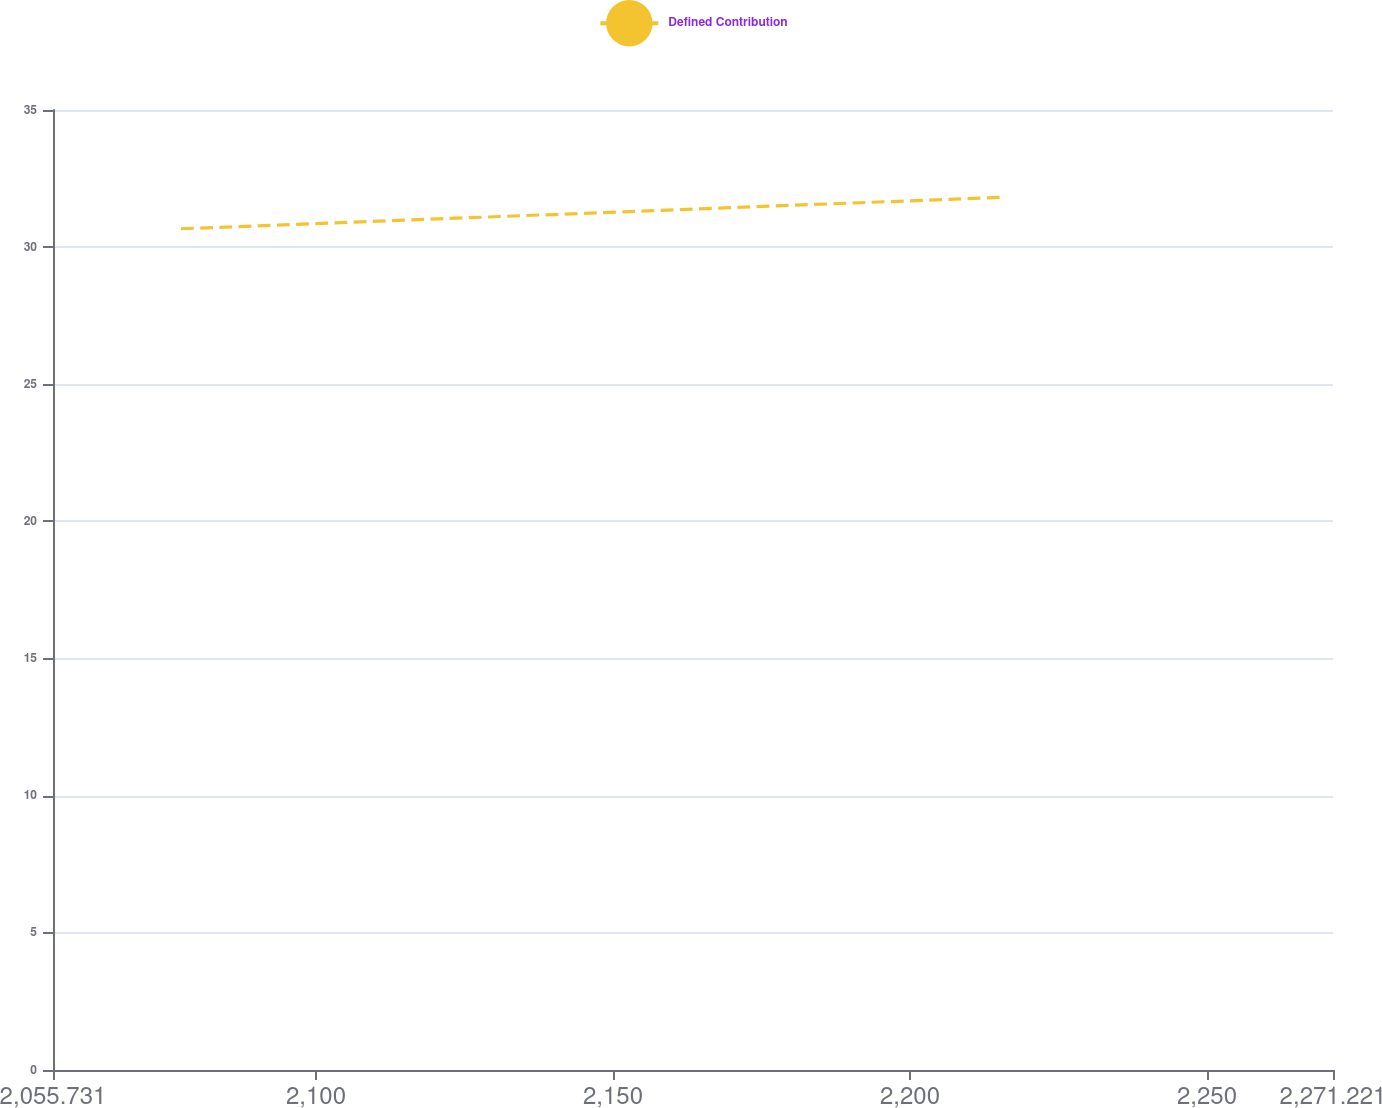Convert chart to OTSL. <chart><loc_0><loc_0><loc_500><loc_500><line_chart><ecel><fcel>Defined Contribution<nl><fcel>2077.28<fcel>30.67<nl><fcel>2215.68<fcel>31.82<nl><fcel>2292.77<fcel>33.6<nl></chart> 